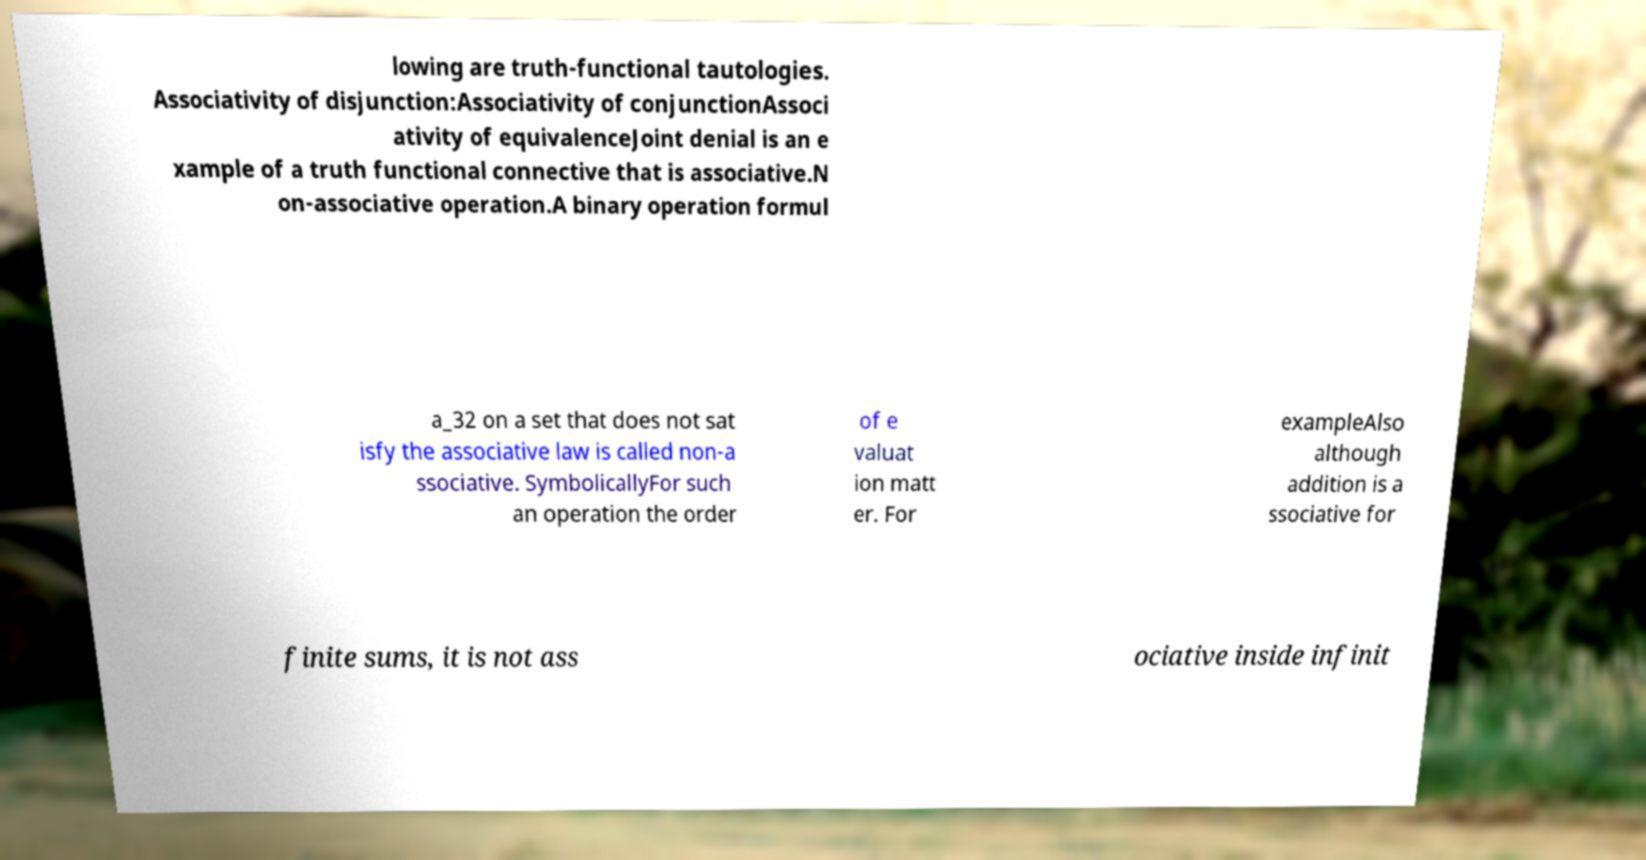Could you assist in decoding the text presented in this image and type it out clearly? lowing are truth-functional tautologies. Associativity of disjunction:Associativity of conjunctionAssoci ativity of equivalenceJoint denial is an e xample of a truth functional connective that is associative.N on-associative operation.A binary operation formul a_32 on a set that does not sat isfy the associative law is called non-a ssociative. SymbolicallyFor such an operation the order of e valuat ion matt er. For exampleAlso although addition is a ssociative for finite sums, it is not ass ociative inside infinit 